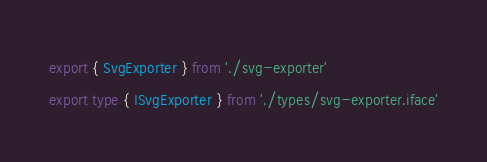Convert code to text. <code><loc_0><loc_0><loc_500><loc_500><_TypeScript_>export { SvgExporter } from './svg-exporter'
export type { ISvgExporter } from './types/svg-exporter.iface'
</code> 